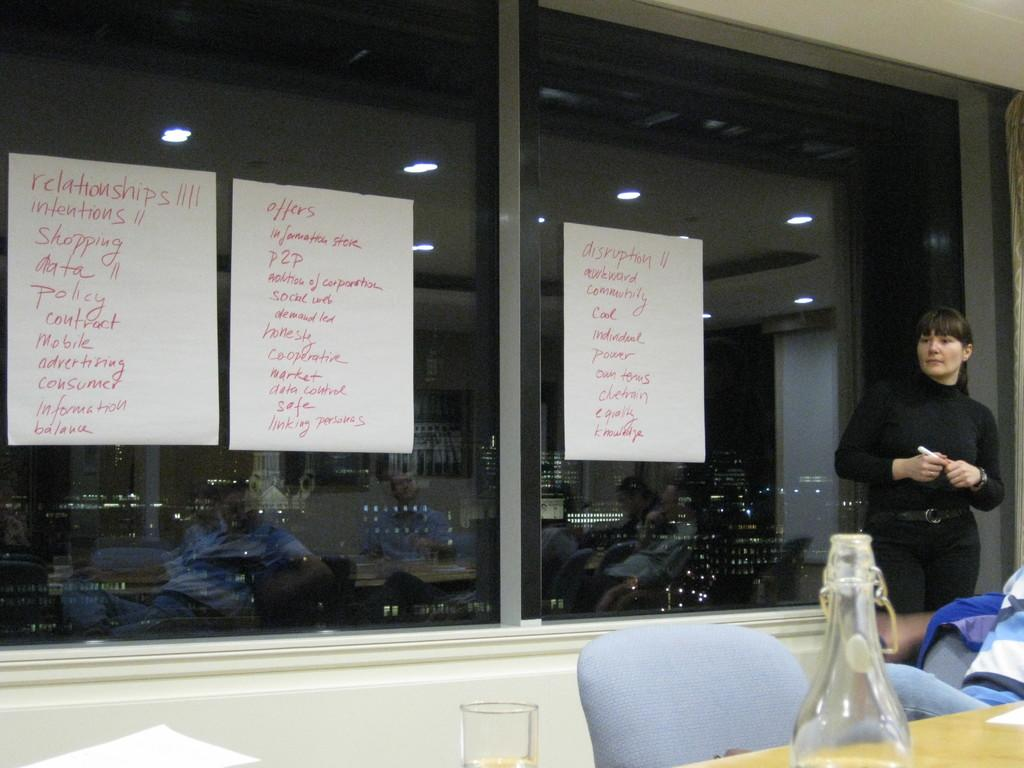What is the primary subject in the image? There is a woman standing in the image. What objects are present in the image besides the woman? There are chairs, a bottle, a glass, and three papers in the image. Where are the bottle and glass located? The bottle and glass are on a table in the image. What can be found on the papers? There is writing on the papers. How does the heat affect the lamp in the image? There is no lamp present in the image, so the heat's effect cannot be determined. Can you describe the bee's behavior in the image? There is no bee present in the image, so its behavior cannot be described. 